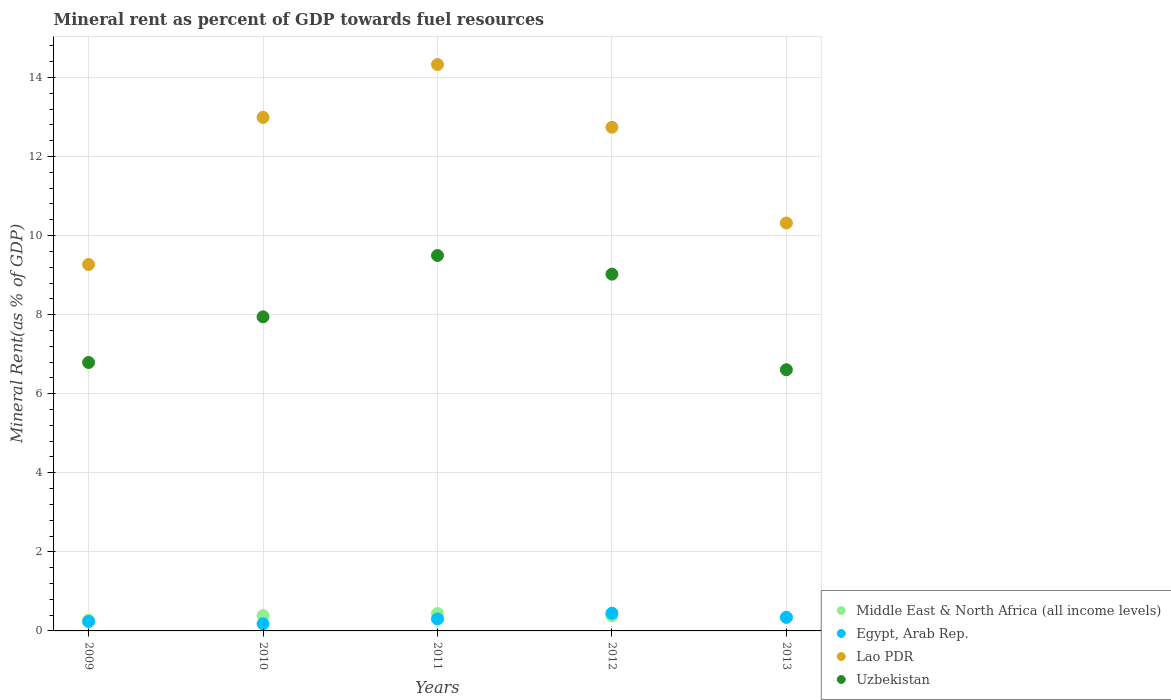How many different coloured dotlines are there?
Make the answer very short. 4. What is the mineral rent in Middle East & North Africa (all income levels) in 2013?
Keep it short and to the point. 0.34. Across all years, what is the maximum mineral rent in Egypt, Arab Rep.?
Your response must be concise. 0.45. Across all years, what is the minimum mineral rent in Uzbekistan?
Your answer should be very brief. 6.61. In which year was the mineral rent in Egypt, Arab Rep. maximum?
Give a very brief answer. 2012. What is the total mineral rent in Middle East & North Africa (all income levels) in the graph?
Provide a succinct answer. 1.82. What is the difference between the mineral rent in Middle East & North Africa (all income levels) in 2009 and that in 2013?
Your answer should be very brief. -0.07. What is the difference between the mineral rent in Middle East & North Africa (all income levels) in 2012 and the mineral rent in Lao PDR in 2010?
Offer a very short reply. -12.61. What is the average mineral rent in Middle East & North Africa (all income levels) per year?
Your answer should be compact. 0.36. In the year 2013, what is the difference between the mineral rent in Lao PDR and mineral rent in Uzbekistan?
Give a very brief answer. 3.71. What is the ratio of the mineral rent in Egypt, Arab Rep. in 2009 to that in 2012?
Make the answer very short. 0.53. Is the mineral rent in Uzbekistan in 2010 less than that in 2012?
Provide a short and direct response. Yes. Is the difference between the mineral rent in Lao PDR in 2010 and 2012 greater than the difference between the mineral rent in Uzbekistan in 2010 and 2012?
Offer a very short reply. Yes. What is the difference between the highest and the second highest mineral rent in Lao PDR?
Make the answer very short. 1.34. What is the difference between the highest and the lowest mineral rent in Egypt, Arab Rep.?
Offer a very short reply. 0.27. In how many years, is the mineral rent in Middle East & North Africa (all income levels) greater than the average mineral rent in Middle East & North Africa (all income levels) taken over all years?
Offer a very short reply. 3. Is the sum of the mineral rent in Egypt, Arab Rep. in 2010 and 2011 greater than the maximum mineral rent in Uzbekistan across all years?
Your response must be concise. No. Is it the case that in every year, the sum of the mineral rent in Middle East & North Africa (all income levels) and mineral rent in Uzbekistan  is greater than the mineral rent in Lao PDR?
Give a very brief answer. No. Is the mineral rent in Egypt, Arab Rep. strictly less than the mineral rent in Middle East & North Africa (all income levels) over the years?
Offer a very short reply. No. Are the values on the major ticks of Y-axis written in scientific E-notation?
Make the answer very short. No. What is the title of the graph?
Your response must be concise. Mineral rent as percent of GDP towards fuel resources. What is the label or title of the Y-axis?
Your response must be concise. Mineral Rent(as % of GDP). What is the Mineral Rent(as % of GDP) in Middle East & North Africa (all income levels) in 2009?
Provide a succinct answer. 0.27. What is the Mineral Rent(as % of GDP) in Egypt, Arab Rep. in 2009?
Offer a very short reply. 0.24. What is the Mineral Rent(as % of GDP) of Lao PDR in 2009?
Provide a succinct answer. 9.27. What is the Mineral Rent(as % of GDP) in Uzbekistan in 2009?
Your answer should be very brief. 6.79. What is the Mineral Rent(as % of GDP) in Middle East & North Africa (all income levels) in 2010?
Provide a short and direct response. 0.39. What is the Mineral Rent(as % of GDP) of Egypt, Arab Rep. in 2010?
Ensure brevity in your answer.  0.18. What is the Mineral Rent(as % of GDP) in Lao PDR in 2010?
Offer a terse response. 12.99. What is the Mineral Rent(as % of GDP) in Uzbekistan in 2010?
Your answer should be compact. 7.95. What is the Mineral Rent(as % of GDP) of Middle East & North Africa (all income levels) in 2011?
Make the answer very short. 0.44. What is the Mineral Rent(as % of GDP) of Egypt, Arab Rep. in 2011?
Offer a terse response. 0.3. What is the Mineral Rent(as % of GDP) in Lao PDR in 2011?
Your answer should be compact. 14.33. What is the Mineral Rent(as % of GDP) of Uzbekistan in 2011?
Offer a very short reply. 9.5. What is the Mineral Rent(as % of GDP) in Middle East & North Africa (all income levels) in 2012?
Your answer should be very brief. 0.38. What is the Mineral Rent(as % of GDP) of Egypt, Arab Rep. in 2012?
Provide a succinct answer. 0.45. What is the Mineral Rent(as % of GDP) in Lao PDR in 2012?
Ensure brevity in your answer.  12.74. What is the Mineral Rent(as % of GDP) in Uzbekistan in 2012?
Your answer should be compact. 9.03. What is the Mineral Rent(as % of GDP) of Middle East & North Africa (all income levels) in 2013?
Provide a short and direct response. 0.34. What is the Mineral Rent(as % of GDP) in Egypt, Arab Rep. in 2013?
Make the answer very short. 0.35. What is the Mineral Rent(as % of GDP) of Lao PDR in 2013?
Your response must be concise. 10.32. What is the Mineral Rent(as % of GDP) of Uzbekistan in 2013?
Offer a terse response. 6.61. Across all years, what is the maximum Mineral Rent(as % of GDP) of Middle East & North Africa (all income levels)?
Provide a short and direct response. 0.44. Across all years, what is the maximum Mineral Rent(as % of GDP) in Egypt, Arab Rep.?
Ensure brevity in your answer.  0.45. Across all years, what is the maximum Mineral Rent(as % of GDP) in Lao PDR?
Give a very brief answer. 14.33. Across all years, what is the maximum Mineral Rent(as % of GDP) in Uzbekistan?
Keep it short and to the point. 9.5. Across all years, what is the minimum Mineral Rent(as % of GDP) of Middle East & North Africa (all income levels)?
Offer a terse response. 0.27. Across all years, what is the minimum Mineral Rent(as % of GDP) in Egypt, Arab Rep.?
Provide a succinct answer. 0.18. Across all years, what is the minimum Mineral Rent(as % of GDP) of Lao PDR?
Provide a succinct answer. 9.27. Across all years, what is the minimum Mineral Rent(as % of GDP) in Uzbekistan?
Your answer should be compact. 6.61. What is the total Mineral Rent(as % of GDP) of Middle East & North Africa (all income levels) in the graph?
Provide a succinct answer. 1.82. What is the total Mineral Rent(as % of GDP) of Egypt, Arab Rep. in the graph?
Give a very brief answer. 1.52. What is the total Mineral Rent(as % of GDP) of Lao PDR in the graph?
Give a very brief answer. 59.65. What is the total Mineral Rent(as % of GDP) of Uzbekistan in the graph?
Keep it short and to the point. 39.87. What is the difference between the Mineral Rent(as % of GDP) in Middle East & North Africa (all income levels) in 2009 and that in 2010?
Give a very brief answer. -0.12. What is the difference between the Mineral Rent(as % of GDP) of Egypt, Arab Rep. in 2009 and that in 2010?
Ensure brevity in your answer.  0.06. What is the difference between the Mineral Rent(as % of GDP) in Lao PDR in 2009 and that in 2010?
Give a very brief answer. -3.72. What is the difference between the Mineral Rent(as % of GDP) of Uzbekistan in 2009 and that in 2010?
Your answer should be compact. -1.16. What is the difference between the Mineral Rent(as % of GDP) of Middle East & North Africa (all income levels) in 2009 and that in 2011?
Keep it short and to the point. -0.17. What is the difference between the Mineral Rent(as % of GDP) in Egypt, Arab Rep. in 2009 and that in 2011?
Make the answer very short. -0.06. What is the difference between the Mineral Rent(as % of GDP) of Lao PDR in 2009 and that in 2011?
Ensure brevity in your answer.  -5.06. What is the difference between the Mineral Rent(as % of GDP) of Uzbekistan in 2009 and that in 2011?
Make the answer very short. -2.71. What is the difference between the Mineral Rent(as % of GDP) of Middle East & North Africa (all income levels) in 2009 and that in 2012?
Offer a terse response. -0.11. What is the difference between the Mineral Rent(as % of GDP) of Egypt, Arab Rep. in 2009 and that in 2012?
Provide a short and direct response. -0.21. What is the difference between the Mineral Rent(as % of GDP) of Lao PDR in 2009 and that in 2012?
Provide a succinct answer. -3.47. What is the difference between the Mineral Rent(as % of GDP) in Uzbekistan in 2009 and that in 2012?
Provide a short and direct response. -2.23. What is the difference between the Mineral Rent(as % of GDP) of Middle East & North Africa (all income levels) in 2009 and that in 2013?
Offer a terse response. -0.07. What is the difference between the Mineral Rent(as % of GDP) in Egypt, Arab Rep. in 2009 and that in 2013?
Make the answer very short. -0.11. What is the difference between the Mineral Rent(as % of GDP) in Lao PDR in 2009 and that in 2013?
Make the answer very short. -1.05. What is the difference between the Mineral Rent(as % of GDP) of Uzbekistan in 2009 and that in 2013?
Keep it short and to the point. 0.18. What is the difference between the Mineral Rent(as % of GDP) of Middle East & North Africa (all income levels) in 2010 and that in 2011?
Offer a terse response. -0.05. What is the difference between the Mineral Rent(as % of GDP) of Egypt, Arab Rep. in 2010 and that in 2011?
Make the answer very short. -0.12. What is the difference between the Mineral Rent(as % of GDP) in Lao PDR in 2010 and that in 2011?
Offer a terse response. -1.34. What is the difference between the Mineral Rent(as % of GDP) in Uzbekistan in 2010 and that in 2011?
Your answer should be compact. -1.55. What is the difference between the Mineral Rent(as % of GDP) in Middle East & North Africa (all income levels) in 2010 and that in 2012?
Make the answer very short. 0.01. What is the difference between the Mineral Rent(as % of GDP) of Egypt, Arab Rep. in 2010 and that in 2012?
Keep it short and to the point. -0.27. What is the difference between the Mineral Rent(as % of GDP) in Lao PDR in 2010 and that in 2012?
Provide a succinct answer. 0.25. What is the difference between the Mineral Rent(as % of GDP) in Uzbekistan in 2010 and that in 2012?
Your response must be concise. -1.08. What is the difference between the Mineral Rent(as % of GDP) of Middle East & North Africa (all income levels) in 2010 and that in 2013?
Provide a succinct answer. 0.05. What is the difference between the Mineral Rent(as % of GDP) in Egypt, Arab Rep. in 2010 and that in 2013?
Your answer should be compact. -0.16. What is the difference between the Mineral Rent(as % of GDP) in Lao PDR in 2010 and that in 2013?
Make the answer very short. 2.67. What is the difference between the Mineral Rent(as % of GDP) of Uzbekistan in 2010 and that in 2013?
Provide a short and direct response. 1.34. What is the difference between the Mineral Rent(as % of GDP) in Middle East & North Africa (all income levels) in 2011 and that in 2012?
Keep it short and to the point. 0.06. What is the difference between the Mineral Rent(as % of GDP) of Egypt, Arab Rep. in 2011 and that in 2012?
Keep it short and to the point. -0.14. What is the difference between the Mineral Rent(as % of GDP) of Lao PDR in 2011 and that in 2012?
Provide a short and direct response. 1.59. What is the difference between the Mineral Rent(as % of GDP) of Uzbekistan in 2011 and that in 2012?
Your answer should be compact. 0.47. What is the difference between the Mineral Rent(as % of GDP) of Middle East & North Africa (all income levels) in 2011 and that in 2013?
Your answer should be compact. 0.11. What is the difference between the Mineral Rent(as % of GDP) of Egypt, Arab Rep. in 2011 and that in 2013?
Keep it short and to the point. -0.04. What is the difference between the Mineral Rent(as % of GDP) in Lao PDR in 2011 and that in 2013?
Offer a very short reply. 4.01. What is the difference between the Mineral Rent(as % of GDP) in Uzbekistan in 2011 and that in 2013?
Provide a short and direct response. 2.89. What is the difference between the Mineral Rent(as % of GDP) of Middle East & North Africa (all income levels) in 2012 and that in 2013?
Make the answer very short. 0.05. What is the difference between the Mineral Rent(as % of GDP) of Egypt, Arab Rep. in 2012 and that in 2013?
Offer a very short reply. 0.1. What is the difference between the Mineral Rent(as % of GDP) of Lao PDR in 2012 and that in 2013?
Ensure brevity in your answer.  2.42. What is the difference between the Mineral Rent(as % of GDP) of Uzbekistan in 2012 and that in 2013?
Make the answer very short. 2.42. What is the difference between the Mineral Rent(as % of GDP) of Middle East & North Africa (all income levels) in 2009 and the Mineral Rent(as % of GDP) of Egypt, Arab Rep. in 2010?
Make the answer very short. 0.09. What is the difference between the Mineral Rent(as % of GDP) in Middle East & North Africa (all income levels) in 2009 and the Mineral Rent(as % of GDP) in Lao PDR in 2010?
Keep it short and to the point. -12.72. What is the difference between the Mineral Rent(as % of GDP) of Middle East & North Africa (all income levels) in 2009 and the Mineral Rent(as % of GDP) of Uzbekistan in 2010?
Your answer should be compact. -7.68. What is the difference between the Mineral Rent(as % of GDP) of Egypt, Arab Rep. in 2009 and the Mineral Rent(as % of GDP) of Lao PDR in 2010?
Offer a terse response. -12.75. What is the difference between the Mineral Rent(as % of GDP) of Egypt, Arab Rep. in 2009 and the Mineral Rent(as % of GDP) of Uzbekistan in 2010?
Give a very brief answer. -7.71. What is the difference between the Mineral Rent(as % of GDP) of Lao PDR in 2009 and the Mineral Rent(as % of GDP) of Uzbekistan in 2010?
Offer a terse response. 1.32. What is the difference between the Mineral Rent(as % of GDP) of Middle East & North Africa (all income levels) in 2009 and the Mineral Rent(as % of GDP) of Egypt, Arab Rep. in 2011?
Ensure brevity in your answer.  -0.03. What is the difference between the Mineral Rent(as % of GDP) in Middle East & North Africa (all income levels) in 2009 and the Mineral Rent(as % of GDP) in Lao PDR in 2011?
Offer a very short reply. -14.06. What is the difference between the Mineral Rent(as % of GDP) of Middle East & North Africa (all income levels) in 2009 and the Mineral Rent(as % of GDP) of Uzbekistan in 2011?
Provide a short and direct response. -9.23. What is the difference between the Mineral Rent(as % of GDP) in Egypt, Arab Rep. in 2009 and the Mineral Rent(as % of GDP) in Lao PDR in 2011?
Keep it short and to the point. -14.09. What is the difference between the Mineral Rent(as % of GDP) in Egypt, Arab Rep. in 2009 and the Mineral Rent(as % of GDP) in Uzbekistan in 2011?
Your response must be concise. -9.26. What is the difference between the Mineral Rent(as % of GDP) in Lao PDR in 2009 and the Mineral Rent(as % of GDP) in Uzbekistan in 2011?
Make the answer very short. -0.23. What is the difference between the Mineral Rent(as % of GDP) of Middle East & North Africa (all income levels) in 2009 and the Mineral Rent(as % of GDP) of Egypt, Arab Rep. in 2012?
Provide a short and direct response. -0.18. What is the difference between the Mineral Rent(as % of GDP) in Middle East & North Africa (all income levels) in 2009 and the Mineral Rent(as % of GDP) in Lao PDR in 2012?
Give a very brief answer. -12.47. What is the difference between the Mineral Rent(as % of GDP) in Middle East & North Africa (all income levels) in 2009 and the Mineral Rent(as % of GDP) in Uzbekistan in 2012?
Your answer should be very brief. -8.76. What is the difference between the Mineral Rent(as % of GDP) of Egypt, Arab Rep. in 2009 and the Mineral Rent(as % of GDP) of Lao PDR in 2012?
Keep it short and to the point. -12.5. What is the difference between the Mineral Rent(as % of GDP) in Egypt, Arab Rep. in 2009 and the Mineral Rent(as % of GDP) in Uzbekistan in 2012?
Keep it short and to the point. -8.79. What is the difference between the Mineral Rent(as % of GDP) in Lao PDR in 2009 and the Mineral Rent(as % of GDP) in Uzbekistan in 2012?
Offer a very short reply. 0.24. What is the difference between the Mineral Rent(as % of GDP) of Middle East & North Africa (all income levels) in 2009 and the Mineral Rent(as % of GDP) of Egypt, Arab Rep. in 2013?
Make the answer very short. -0.08. What is the difference between the Mineral Rent(as % of GDP) in Middle East & North Africa (all income levels) in 2009 and the Mineral Rent(as % of GDP) in Lao PDR in 2013?
Give a very brief answer. -10.05. What is the difference between the Mineral Rent(as % of GDP) of Middle East & North Africa (all income levels) in 2009 and the Mineral Rent(as % of GDP) of Uzbekistan in 2013?
Provide a succinct answer. -6.34. What is the difference between the Mineral Rent(as % of GDP) of Egypt, Arab Rep. in 2009 and the Mineral Rent(as % of GDP) of Lao PDR in 2013?
Your answer should be very brief. -10.08. What is the difference between the Mineral Rent(as % of GDP) of Egypt, Arab Rep. in 2009 and the Mineral Rent(as % of GDP) of Uzbekistan in 2013?
Make the answer very short. -6.37. What is the difference between the Mineral Rent(as % of GDP) in Lao PDR in 2009 and the Mineral Rent(as % of GDP) in Uzbekistan in 2013?
Your answer should be very brief. 2.66. What is the difference between the Mineral Rent(as % of GDP) in Middle East & North Africa (all income levels) in 2010 and the Mineral Rent(as % of GDP) in Egypt, Arab Rep. in 2011?
Provide a short and direct response. 0.09. What is the difference between the Mineral Rent(as % of GDP) of Middle East & North Africa (all income levels) in 2010 and the Mineral Rent(as % of GDP) of Lao PDR in 2011?
Make the answer very short. -13.94. What is the difference between the Mineral Rent(as % of GDP) in Middle East & North Africa (all income levels) in 2010 and the Mineral Rent(as % of GDP) in Uzbekistan in 2011?
Keep it short and to the point. -9.11. What is the difference between the Mineral Rent(as % of GDP) in Egypt, Arab Rep. in 2010 and the Mineral Rent(as % of GDP) in Lao PDR in 2011?
Make the answer very short. -14.15. What is the difference between the Mineral Rent(as % of GDP) in Egypt, Arab Rep. in 2010 and the Mineral Rent(as % of GDP) in Uzbekistan in 2011?
Your response must be concise. -9.32. What is the difference between the Mineral Rent(as % of GDP) in Lao PDR in 2010 and the Mineral Rent(as % of GDP) in Uzbekistan in 2011?
Your answer should be compact. 3.49. What is the difference between the Mineral Rent(as % of GDP) of Middle East & North Africa (all income levels) in 2010 and the Mineral Rent(as % of GDP) of Egypt, Arab Rep. in 2012?
Offer a very short reply. -0.06. What is the difference between the Mineral Rent(as % of GDP) in Middle East & North Africa (all income levels) in 2010 and the Mineral Rent(as % of GDP) in Lao PDR in 2012?
Provide a succinct answer. -12.35. What is the difference between the Mineral Rent(as % of GDP) of Middle East & North Africa (all income levels) in 2010 and the Mineral Rent(as % of GDP) of Uzbekistan in 2012?
Ensure brevity in your answer.  -8.64. What is the difference between the Mineral Rent(as % of GDP) of Egypt, Arab Rep. in 2010 and the Mineral Rent(as % of GDP) of Lao PDR in 2012?
Provide a succinct answer. -12.56. What is the difference between the Mineral Rent(as % of GDP) in Egypt, Arab Rep. in 2010 and the Mineral Rent(as % of GDP) in Uzbekistan in 2012?
Make the answer very short. -8.84. What is the difference between the Mineral Rent(as % of GDP) of Lao PDR in 2010 and the Mineral Rent(as % of GDP) of Uzbekistan in 2012?
Ensure brevity in your answer.  3.97. What is the difference between the Mineral Rent(as % of GDP) in Middle East & North Africa (all income levels) in 2010 and the Mineral Rent(as % of GDP) in Egypt, Arab Rep. in 2013?
Give a very brief answer. 0.04. What is the difference between the Mineral Rent(as % of GDP) of Middle East & North Africa (all income levels) in 2010 and the Mineral Rent(as % of GDP) of Lao PDR in 2013?
Offer a terse response. -9.93. What is the difference between the Mineral Rent(as % of GDP) of Middle East & North Africa (all income levels) in 2010 and the Mineral Rent(as % of GDP) of Uzbekistan in 2013?
Keep it short and to the point. -6.22. What is the difference between the Mineral Rent(as % of GDP) of Egypt, Arab Rep. in 2010 and the Mineral Rent(as % of GDP) of Lao PDR in 2013?
Offer a very short reply. -10.14. What is the difference between the Mineral Rent(as % of GDP) of Egypt, Arab Rep. in 2010 and the Mineral Rent(as % of GDP) of Uzbekistan in 2013?
Ensure brevity in your answer.  -6.43. What is the difference between the Mineral Rent(as % of GDP) of Lao PDR in 2010 and the Mineral Rent(as % of GDP) of Uzbekistan in 2013?
Your answer should be compact. 6.38. What is the difference between the Mineral Rent(as % of GDP) of Middle East & North Africa (all income levels) in 2011 and the Mineral Rent(as % of GDP) of Egypt, Arab Rep. in 2012?
Your response must be concise. -0.01. What is the difference between the Mineral Rent(as % of GDP) in Middle East & North Africa (all income levels) in 2011 and the Mineral Rent(as % of GDP) in Lao PDR in 2012?
Provide a short and direct response. -12.3. What is the difference between the Mineral Rent(as % of GDP) in Middle East & North Africa (all income levels) in 2011 and the Mineral Rent(as % of GDP) in Uzbekistan in 2012?
Your answer should be compact. -8.58. What is the difference between the Mineral Rent(as % of GDP) in Egypt, Arab Rep. in 2011 and the Mineral Rent(as % of GDP) in Lao PDR in 2012?
Provide a succinct answer. -12.44. What is the difference between the Mineral Rent(as % of GDP) of Egypt, Arab Rep. in 2011 and the Mineral Rent(as % of GDP) of Uzbekistan in 2012?
Make the answer very short. -8.72. What is the difference between the Mineral Rent(as % of GDP) of Lao PDR in 2011 and the Mineral Rent(as % of GDP) of Uzbekistan in 2012?
Your answer should be compact. 5.3. What is the difference between the Mineral Rent(as % of GDP) in Middle East & North Africa (all income levels) in 2011 and the Mineral Rent(as % of GDP) in Egypt, Arab Rep. in 2013?
Provide a short and direct response. 0.09. What is the difference between the Mineral Rent(as % of GDP) of Middle East & North Africa (all income levels) in 2011 and the Mineral Rent(as % of GDP) of Lao PDR in 2013?
Ensure brevity in your answer.  -9.88. What is the difference between the Mineral Rent(as % of GDP) in Middle East & North Africa (all income levels) in 2011 and the Mineral Rent(as % of GDP) in Uzbekistan in 2013?
Make the answer very short. -6.17. What is the difference between the Mineral Rent(as % of GDP) of Egypt, Arab Rep. in 2011 and the Mineral Rent(as % of GDP) of Lao PDR in 2013?
Ensure brevity in your answer.  -10.02. What is the difference between the Mineral Rent(as % of GDP) in Egypt, Arab Rep. in 2011 and the Mineral Rent(as % of GDP) in Uzbekistan in 2013?
Keep it short and to the point. -6.3. What is the difference between the Mineral Rent(as % of GDP) in Lao PDR in 2011 and the Mineral Rent(as % of GDP) in Uzbekistan in 2013?
Provide a succinct answer. 7.72. What is the difference between the Mineral Rent(as % of GDP) in Middle East & North Africa (all income levels) in 2012 and the Mineral Rent(as % of GDP) in Egypt, Arab Rep. in 2013?
Your answer should be compact. 0.04. What is the difference between the Mineral Rent(as % of GDP) of Middle East & North Africa (all income levels) in 2012 and the Mineral Rent(as % of GDP) of Lao PDR in 2013?
Keep it short and to the point. -9.94. What is the difference between the Mineral Rent(as % of GDP) of Middle East & North Africa (all income levels) in 2012 and the Mineral Rent(as % of GDP) of Uzbekistan in 2013?
Your answer should be very brief. -6.22. What is the difference between the Mineral Rent(as % of GDP) of Egypt, Arab Rep. in 2012 and the Mineral Rent(as % of GDP) of Lao PDR in 2013?
Provide a succinct answer. -9.87. What is the difference between the Mineral Rent(as % of GDP) of Egypt, Arab Rep. in 2012 and the Mineral Rent(as % of GDP) of Uzbekistan in 2013?
Your answer should be compact. -6.16. What is the difference between the Mineral Rent(as % of GDP) in Lao PDR in 2012 and the Mineral Rent(as % of GDP) in Uzbekistan in 2013?
Keep it short and to the point. 6.13. What is the average Mineral Rent(as % of GDP) of Middle East & North Africa (all income levels) per year?
Give a very brief answer. 0.36. What is the average Mineral Rent(as % of GDP) of Egypt, Arab Rep. per year?
Provide a short and direct response. 0.3. What is the average Mineral Rent(as % of GDP) in Lao PDR per year?
Offer a very short reply. 11.93. What is the average Mineral Rent(as % of GDP) of Uzbekistan per year?
Your answer should be very brief. 7.97. In the year 2009, what is the difference between the Mineral Rent(as % of GDP) in Middle East & North Africa (all income levels) and Mineral Rent(as % of GDP) in Egypt, Arab Rep.?
Ensure brevity in your answer.  0.03. In the year 2009, what is the difference between the Mineral Rent(as % of GDP) in Middle East & North Africa (all income levels) and Mineral Rent(as % of GDP) in Lao PDR?
Your answer should be compact. -9. In the year 2009, what is the difference between the Mineral Rent(as % of GDP) of Middle East & North Africa (all income levels) and Mineral Rent(as % of GDP) of Uzbekistan?
Your response must be concise. -6.52. In the year 2009, what is the difference between the Mineral Rent(as % of GDP) of Egypt, Arab Rep. and Mineral Rent(as % of GDP) of Lao PDR?
Offer a terse response. -9.03. In the year 2009, what is the difference between the Mineral Rent(as % of GDP) of Egypt, Arab Rep. and Mineral Rent(as % of GDP) of Uzbekistan?
Your response must be concise. -6.55. In the year 2009, what is the difference between the Mineral Rent(as % of GDP) of Lao PDR and Mineral Rent(as % of GDP) of Uzbekistan?
Make the answer very short. 2.48. In the year 2010, what is the difference between the Mineral Rent(as % of GDP) in Middle East & North Africa (all income levels) and Mineral Rent(as % of GDP) in Egypt, Arab Rep.?
Your response must be concise. 0.21. In the year 2010, what is the difference between the Mineral Rent(as % of GDP) in Middle East & North Africa (all income levels) and Mineral Rent(as % of GDP) in Lao PDR?
Your answer should be very brief. -12.6. In the year 2010, what is the difference between the Mineral Rent(as % of GDP) in Middle East & North Africa (all income levels) and Mineral Rent(as % of GDP) in Uzbekistan?
Provide a succinct answer. -7.56. In the year 2010, what is the difference between the Mineral Rent(as % of GDP) in Egypt, Arab Rep. and Mineral Rent(as % of GDP) in Lao PDR?
Provide a succinct answer. -12.81. In the year 2010, what is the difference between the Mineral Rent(as % of GDP) in Egypt, Arab Rep. and Mineral Rent(as % of GDP) in Uzbekistan?
Your response must be concise. -7.76. In the year 2010, what is the difference between the Mineral Rent(as % of GDP) of Lao PDR and Mineral Rent(as % of GDP) of Uzbekistan?
Provide a succinct answer. 5.05. In the year 2011, what is the difference between the Mineral Rent(as % of GDP) of Middle East & North Africa (all income levels) and Mineral Rent(as % of GDP) of Egypt, Arab Rep.?
Ensure brevity in your answer.  0.14. In the year 2011, what is the difference between the Mineral Rent(as % of GDP) in Middle East & North Africa (all income levels) and Mineral Rent(as % of GDP) in Lao PDR?
Your answer should be compact. -13.89. In the year 2011, what is the difference between the Mineral Rent(as % of GDP) in Middle East & North Africa (all income levels) and Mineral Rent(as % of GDP) in Uzbekistan?
Offer a very short reply. -9.06. In the year 2011, what is the difference between the Mineral Rent(as % of GDP) in Egypt, Arab Rep. and Mineral Rent(as % of GDP) in Lao PDR?
Provide a short and direct response. -14.02. In the year 2011, what is the difference between the Mineral Rent(as % of GDP) of Egypt, Arab Rep. and Mineral Rent(as % of GDP) of Uzbekistan?
Your response must be concise. -9.19. In the year 2011, what is the difference between the Mineral Rent(as % of GDP) in Lao PDR and Mineral Rent(as % of GDP) in Uzbekistan?
Keep it short and to the point. 4.83. In the year 2012, what is the difference between the Mineral Rent(as % of GDP) of Middle East & North Africa (all income levels) and Mineral Rent(as % of GDP) of Egypt, Arab Rep.?
Keep it short and to the point. -0.06. In the year 2012, what is the difference between the Mineral Rent(as % of GDP) of Middle East & North Africa (all income levels) and Mineral Rent(as % of GDP) of Lao PDR?
Give a very brief answer. -12.36. In the year 2012, what is the difference between the Mineral Rent(as % of GDP) in Middle East & North Africa (all income levels) and Mineral Rent(as % of GDP) in Uzbekistan?
Provide a succinct answer. -8.64. In the year 2012, what is the difference between the Mineral Rent(as % of GDP) in Egypt, Arab Rep. and Mineral Rent(as % of GDP) in Lao PDR?
Offer a terse response. -12.29. In the year 2012, what is the difference between the Mineral Rent(as % of GDP) of Egypt, Arab Rep. and Mineral Rent(as % of GDP) of Uzbekistan?
Offer a terse response. -8.58. In the year 2012, what is the difference between the Mineral Rent(as % of GDP) in Lao PDR and Mineral Rent(as % of GDP) in Uzbekistan?
Offer a terse response. 3.72. In the year 2013, what is the difference between the Mineral Rent(as % of GDP) in Middle East & North Africa (all income levels) and Mineral Rent(as % of GDP) in Egypt, Arab Rep.?
Give a very brief answer. -0.01. In the year 2013, what is the difference between the Mineral Rent(as % of GDP) of Middle East & North Africa (all income levels) and Mineral Rent(as % of GDP) of Lao PDR?
Your response must be concise. -9.98. In the year 2013, what is the difference between the Mineral Rent(as % of GDP) of Middle East & North Africa (all income levels) and Mineral Rent(as % of GDP) of Uzbekistan?
Offer a terse response. -6.27. In the year 2013, what is the difference between the Mineral Rent(as % of GDP) in Egypt, Arab Rep. and Mineral Rent(as % of GDP) in Lao PDR?
Your answer should be compact. -9.97. In the year 2013, what is the difference between the Mineral Rent(as % of GDP) of Egypt, Arab Rep. and Mineral Rent(as % of GDP) of Uzbekistan?
Provide a succinct answer. -6.26. In the year 2013, what is the difference between the Mineral Rent(as % of GDP) in Lao PDR and Mineral Rent(as % of GDP) in Uzbekistan?
Your answer should be compact. 3.71. What is the ratio of the Mineral Rent(as % of GDP) of Middle East & North Africa (all income levels) in 2009 to that in 2010?
Keep it short and to the point. 0.69. What is the ratio of the Mineral Rent(as % of GDP) of Egypt, Arab Rep. in 2009 to that in 2010?
Your response must be concise. 1.31. What is the ratio of the Mineral Rent(as % of GDP) in Lao PDR in 2009 to that in 2010?
Offer a terse response. 0.71. What is the ratio of the Mineral Rent(as % of GDP) in Uzbekistan in 2009 to that in 2010?
Provide a succinct answer. 0.85. What is the ratio of the Mineral Rent(as % of GDP) in Middle East & North Africa (all income levels) in 2009 to that in 2011?
Provide a succinct answer. 0.61. What is the ratio of the Mineral Rent(as % of GDP) in Egypt, Arab Rep. in 2009 to that in 2011?
Make the answer very short. 0.79. What is the ratio of the Mineral Rent(as % of GDP) in Lao PDR in 2009 to that in 2011?
Your answer should be very brief. 0.65. What is the ratio of the Mineral Rent(as % of GDP) of Uzbekistan in 2009 to that in 2011?
Give a very brief answer. 0.71. What is the ratio of the Mineral Rent(as % of GDP) in Middle East & North Africa (all income levels) in 2009 to that in 2012?
Make the answer very short. 0.7. What is the ratio of the Mineral Rent(as % of GDP) in Egypt, Arab Rep. in 2009 to that in 2012?
Your answer should be compact. 0.53. What is the ratio of the Mineral Rent(as % of GDP) in Lao PDR in 2009 to that in 2012?
Provide a short and direct response. 0.73. What is the ratio of the Mineral Rent(as % of GDP) of Uzbekistan in 2009 to that in 2012?
Provide a short and direct response. 0.75. What is the ratio of the Mineral Rent(as % of GDP) of Middle East & North Africa (all income levels) in 2009 to that in 2013?
Give a very brief answer. 0.8. What is the ratio of the Mineral Rent(as % of GDP) in Egypt, Arab Rep. in 2009 to that in 2013?
Your response must be concise. 0.69. What is the ratio of the Mineral Rent(as % of GDP) in Lao PDR in 2009 to that in 2013?
Your answer should be compact. 0.9. What is the ratio of the Mineral Rent(as % of GDP) in Uzbekistan in 2009 to that in 2013?
Your response must be concise. 1.03. What is the ratio of the Mineral Rent(as % of GDP) of Middle East & North Africa (all income levels) in 2010 to that in 2011?
Offer a very short reply. 0.88. What is the ratio of the Mineral Rent(as % of GDP) in Egypt, Arab Rep. in 2010 to that in 2011?
Your answer should be compact. 0.6. What is the ratio of the Mineral Rent(as % of GDP) of Lao PDR in 2010 to that in 2011?
Make the answer very short. 0.91. What is the ratio of the Mineral Rent(as % of GDP) in Uzbekistan in 2010 to that in 2011?
Offer a terse response. 0.84. What is the ratio of the Mineral Rent(as % of GDP) of Middle East & North Africa (all income levels) in 2010 to that in 2012?
Provide a short and direct response. 1.01. What is the ratio of the Mineral Rent(as % of GDP) in Egypt, Arab Rep. in 2010 to that in 2012?
Your answer should be very brief. 0.41. What is the ratio of the Mineral Rent(as % of GDP) of Lao PDR in 2010 to that in 2012?
Your answer should be compact. 1.02. What is the ratio of the Mineral Rent(as % of GDP) of Uzbekistan in 2010 to that in 2012?
Your answer should be compact. 0.88. What is the ratio of the Mineral Rent(as % of GDP) in Middle East & North Africa (all income levels) in 2010 to that in 2013?
Ensure brevity in your answer.  1.16. What is the ratio of the Mineral Rent(as % of GDP) of Egypt, Arab Rep. in 2010 to that in 2013?
Your answer should be very brief. 0.53. What is the ratio of the Mineral Rent(as % of GDP) of Lao PDR in 2010 to that in 2013?
Keep it short and to the point. 1.26. What is the ratio of the Mineral Rent(as % of GDP) of Uzbekistan in 2010 to that in 2013?
Ensure brevity in your answer.  1.2. What is the ratio of the Mineral Rent(as % of GDP) of Middle East & North Africa (all income levels) in 2011 to that in 2012?
Make the answer very short. 1.15. What is the ratio of the Mineral Rent(as % of GDP) in Egypt, Arab Rep. in 2011 to that in 2012?
Your answer should be very brief. 0.68. What is the ratio of the Mineral Rent(as % of GDP) in Lao PDR in 2011 to that in 2012?
Keep it short and to the point. 1.12. What is the ratio of the Mineral Rent(as % of GDP) of Uzbekistan in 2011 to that in 2012?
Provide a short and direct response. 1.05. What is the ratio of the Mineral Rent(as % of GDP) of Middle East & North Africa (all income levels) in 2011 to that in 2013?
Give a very brief answer. 1.31. What is the ratio of the Mineral Rent(as % of GDP) in Egypt, Arab Rep. in 2011 to that in 2013?
Provide a succinct answer. 0.88. What is the ratio of the Mineral Rent(as % of GDP) in Lao PDR in 2011 to that in 2013?
Keep it short and to the point. 1.39. What is the ratio of the Mineral Rent(as % of GDP) in Uzbekistan in 2011 to that in 2013?
Ensure brevity in your answer.  1.44. What is the ratio of the Mineral Rent(as % of GDP) in Middle East & North Africa (all income levels) in 2012 to that in 2013?
Your answer should be very brief. 1.14. What is the ratio of the Mineral Rent(as % of GDP) in Egypt, Arab Rep. in 2012 to that in 2013?
Give a very brief answer. 1.3. What is the ratio of the Mineral Rent(as % of GDP) in Lao PDR in 2012 to that in 2013?
Provide a short and direct response. 1.23. What is the ratio of the Mineral Rent(as % of GDP) of Uzbekistan in 2012 to that in 2013?
Provide a short and direct response. 1.37. What is the difference between the highest and the second highest Mineral Rent(as % of GDP) in Middle East & North Africa (all income levels)?
Your answer should be compact. 0.05. What is the difference between the highest and the second highest Mineral Rent(as % of GDP) in Egypt, Arab Rep.?
Provide a succinct answer. 0.1. What is the difference between the highest and the second highest Mineral Rent(as % of GDP) in Lao PDR?
Make the answer very short. 1.34. What is the difference between the highest and the second highest Mineral Rent(as % of GDP) in Uzbekistan?
Offer a terse response. 0.47. What is the difference between the highest and the lowest Mineral Rent(as % of GDP) of Middle East & North Africa (all income levels)?
Give a very brief answer. 0.17. What is the difference between the highest and the lowest Mineral Rent(as % of GDP) of Egypt, Arab Rep.?
Your answer should be compact. 0.27. What is the difference between the highest and the lowest Mineral Rent(as % of GDP) in Lao PDR?
Provide a succinct answer. 5.06. What is the difference between the highest and the lowest Mineral Rent(as % of GDP) of Uzbekistan?
Make the answer very short. 2.89. 